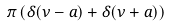<formula> <loc_0><loc_0><loc_500><loc_500>\pi \left ( \delta ( \nu - a ) + \delta ( \nu + a ) \right )</formula> 